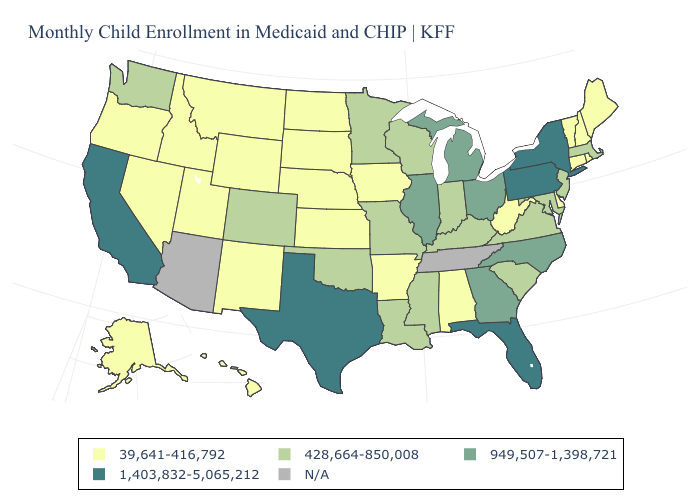Name the states that have a value in the range 428,664-850,008?
Be succinct. Colorado, Indiana, Kentucky, Louisiana, Maryland, Massachusetts, Minnesota, Mississippi, Missouri, New Jersey, Oklahoma, South Carolina, Virginia, Washington, Wisconsin. Does the map have missing data?
Short answer required. Yes. What is the highest value in the USA?
Short answer required. 1,403,832-5,065,212. Which states have the lowest value in the USA?
Concise answer only. Alabama, Alaska, Arkansas, Connecticut, Delaware, Hawaii, Idaho, Iowa, Kansas, Maine, Montana, Nebraska, Nevada, New Hampshire, New Mexico, North Dakota, Oregon, Rhode Island, South Dakota, Utah, Vermont, West Virginia, Wyoming. Does California have the lowest value in the USA?
Short answer required. No. Does Washington have the lowest value in the West?
Be succinct. No. Among the states that border Oklahoma , which have the highest value?
Give a very brief answer. Texas. What is the lowest value in the USA?
Quick response, please. 39,641-416,792. Name the states that have a value in the range 1,403,832-5,065,212?
Be succinct. California, Florida, New York, Pennsylvania, Texas. What is the value of Georgia?
Write a very short answer. 949,507-1,398,721. Does Louisiana have the highest value in the USA?
Write a very short answer. No. What is the lowest value in the West?
Concise answer only. 39,641-416,792. Which states have the lowest value in the MidWest?
Write a very short answer. Iowa, Kansas, Nebraska, North Dakota, South Dakota. Name the states that have a value in the range N/A?
Be succinct. Arizona, Tennessee. Among the states that border Florida , which have the highest value?
Keep it brief. Georgia. 